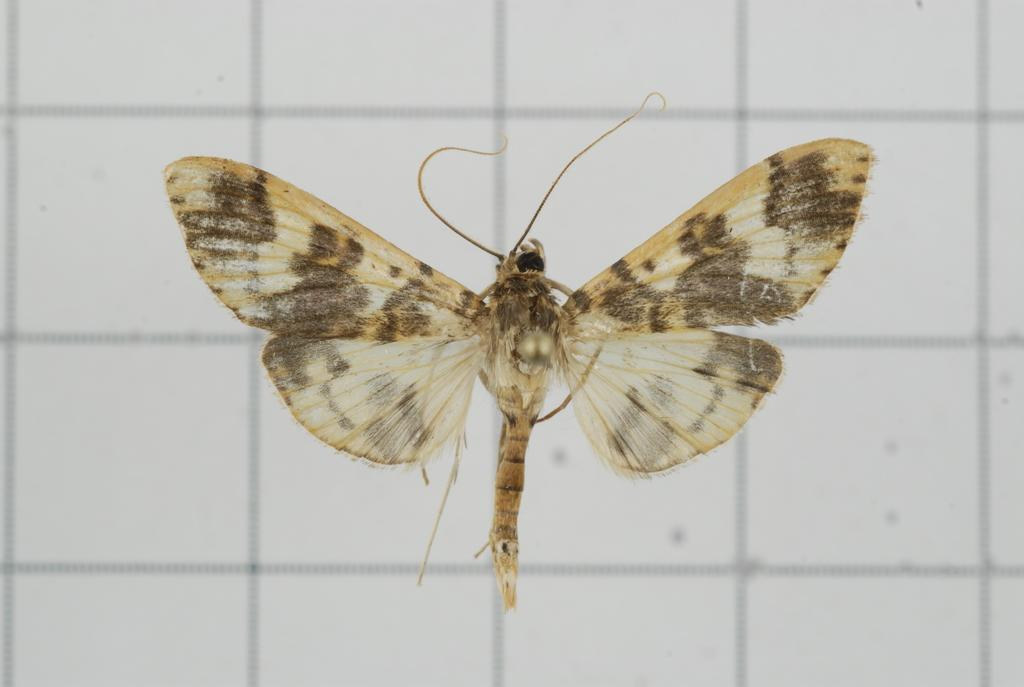What is in the foreground of the image? There is a bee in the foreground of the image. What can be seen in the background of the image? There is a wall in the background of the image. What question is the bee asking in the image? There is no indication in the image that the bee is asking a question, as bees do not have the ability to communicate in this manner. 